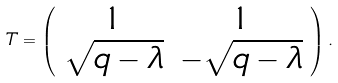<formula> <loc_0><loc_0><loc_500><loc_500>T = \left ( \begin{array} { c c } 1 & 1 \\ \sqrt { q - \lambda } & - \sqrt { q - \lambda } \\ \end{array} \right ) .</formula> 